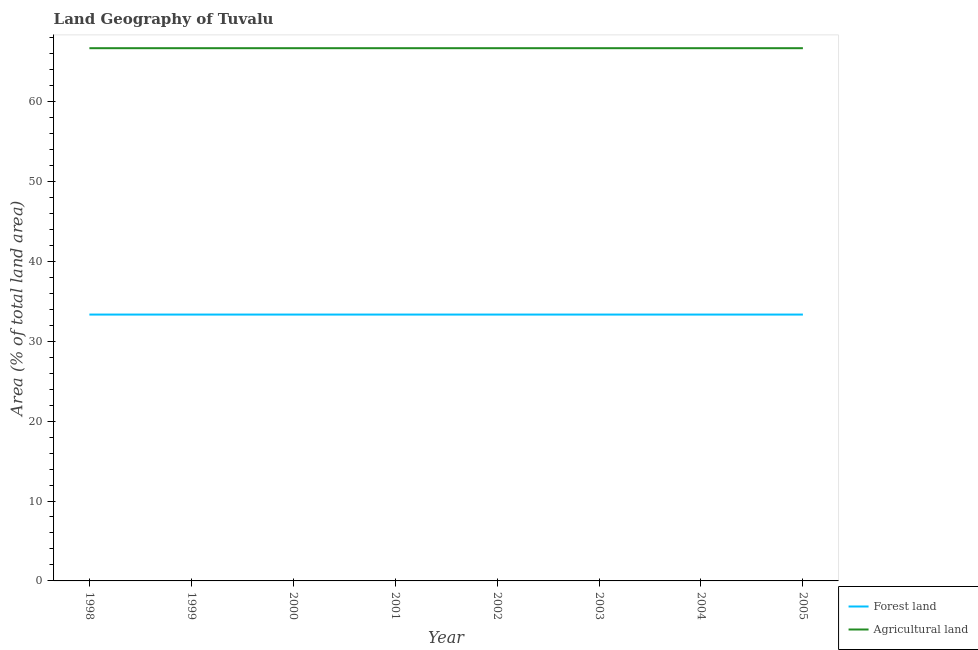Is the number of lines equal to the number of legend labels?
Keep it short and to the point. Yes. What is the percentage of land area under agriculture in 2002?
Your answer should be compact. 66.67. Across all years, what is the maximum percentage of land area under agriculture?
Make the answer very short. 66.67. Across all years, what is the minimum percentage of land area under forests?
Your answer should be very brief. 33.33. In which year was the percentage of land area under forests maximum?
Your answer should be very brief. 1998. What is the total percentage of land area under forests in the graph?
Provide a succinct answer. 266.67. What is the difference between the percentage of land area under agriculture in 2001 and that in 2004?
Provide a short and direct response. 0. What is the difference between the percentage of land area under forests in 1999 and the percentage of land area under agriculture in 2003?
Provide a short and direct response. -33.33. What is the average percentage of land area under forests per year?
Offer a very short reply. 33.33. In the year 2005, what is the difference between the percentage of land area under forests and percentage of land area under agriculture?
Your answer should be compact. -33.33. In how many years, is the percentage of land area under agriculture greater than 6 %?
Provide a short and direct response. 8. What is the ratio of the percentage of land area under forests in 1998 to that in 1999?
Keep it short and to the point. 1. Is the percentage of land area under agriculture in 1998 less than that in 2005?
Make the answer very short. No. What is the difference between the highest and the second highest percentage of land area under forests?
Your response must be concise. 0. In how many years, is the percentage of land area under agriculture greater than the average percentage of land area under agriculture taken over all years?
Offer a very short reply. 0. Does the percentage of land area under forests monotonically increase over the years?
Your response must be concise. No. How many years are there in the graph?
Give a very brief answer. 8. Are the values on the major ticks of Y-axis written in scientific E-notation?
Give a very brief answer. No. Where does the legend appear in the graph?
Your answer should be compact. Bottom right. How many legend labels are there?
Provide a short and direct response. 2. What is the title of the graph?
Offer a terse response. Land Geography of Tuvalu. What is the label or title of the Y-axis?
Provide a short and direct response. Area (% of total land area). What is the Area (% of total land area) of Forest land in 1998?
Keep it short and to the point. 33.33. What is the Area (% of total land area) of Agricultural land in 1998?
Provide a short and direct response. 66.67. What is the Area (% of total land area) in Forest land in 1999?
Provide a succinct answer. 33.33. What is the Area (% of total land area) in Agricultural land in 1999?
Offer a very short reply. 66.67. What is the Area (% of total land area) in Forest land in 2000?
Ensure brevity in your answer.  33.33. What is the Area (% of total land area) in Agricultural land in 2000?
Your answer should be very brief. 66.67. What is the Area (% of total land area) of Forest land in 2001?
Your answer should be compact. 33.33. What is the Area (% of total land area) of Agricultural land in 2001?
Provide a short and direct response. 66.67. What is the Area (% of total land area) in Forest land in 2002?
Your response must be concise. 33.33. What is the Area (% of total land area) in Agricultural land in 2002?
Provide a succinct answer. 66.67. What is the Area (% of total land area) of Forest land in 2003?
Offer a terse response. 33.33. What is the Area (% of total land area) of Agricultural land in 2003?
Provide a succinct answer. 66.67. What is the Area (% of total land area) of Forest land in 2004?
Your answer should be very brief. 33.33. What is the Area (% of total land area) of Agricultural land in 2004?
Provide a succinct answer. 66.67. What is the Area (% of total land area) of Forest land in 2005?
Your answer should be very brief. 33.33. What is the Area (% of total land area) of Agricultural land in 2005?
Your answer should be very brief. 66.67. Across all years, what is the maximum Area (% of total land area) of Forest land?
Your response must be concise. 33.33. Across all years, what is the maximum Area (% of total land area) in Agricultural land?
Ensure brevity in your answer.  66.67. Across all years, what is the minimum Area (% of total land area) of Forest land?
Your response must be concise. 33.33. Across all years, what is the minimum Area (% of total land area) in Agricultural land?
Make the answer very short. 66.67. What is the total Area (% of total land area) of Forest land in the graph?
Offer a very short reply. 266.67. What is the total Area (% of total land area) of Agricultural land in the graph?
Your response must be concise. 533.33. What is the difference between the Area (% of total land area) in Forest land in 1998 and that in 1999?
Keep it short and to the point. 0. What is the difference between the Area (% of total land area) in Agricultural land in 1998 and that in 1999?
Offer a terse response. 0. What is the difference between the Area (% of total land area) in Forest land in 1998 and that in 2000?
Give a very brief answer. 0. What is the difference between the Area (% of total land area) of Forest land in 1998 and that in 2001?
Your answer should be very brief. 0. What is the difference between the Area (% of total land area) in Forest land in 1998 and that in 2002?
Keep it short and to the point. 0. What is the difference between the Area (% of total land area) in Forest land in 1998 and that in 2003?
Offer a very short reply. 0. What is the difference between the Area (% of total land area) of Agricultural land in 1998 and that in 2003?
Ensure brevity in your answer.  0. What is the difference between the Area (% of total land area) of Forest land in 1998 and that in 2004?
Provide a short and direct response. 0. What is the difference between the Area (% of total land area) in Agricultural land in 1998 and that in 2004?
Your answer should be compact. 0. What is the difference between the Area (% of total land area) of Forest land in 1998 and that in 2005?
Your response must be concise. 0. What is the difference between the Area (% of total land area) of Agricultural land in 1999 and that in 2000?
Offer a very short reply. 0. What is the difference between the Area (% of total land area) in Forest land in 1999 and that in 2003?
Provide a succinct answer. 0. What is the difference between the Area (% of total land area) of Agricultural land in 2000 and that in 2001?
Your answer should be very brief. 0. What is the difference between the Area (% of total land area) in Agricultural land in 2000 and that in 2002?
Provide a short and direct response. 0. What is the difference between the Area (% of total land area) in Forest land in 2000 and that in 2003?
Give a very brief answer. 0. What is the difference between the Area (% of total land area) of Agricultural land in 2000 and that in 2003?
Offer a terse response. 0. What is the difference between the Area (% of total land area) of Agricultural land in 2001 and that in 2002?
Provide a succinct answer. 0. What is the difference between the Area (% of total land area) of Agricultural land in 2001 and that in 2003?
Your answer should be compact. 0. What is the difference between the Area (% of total land area) in Forest land in 2001 and that in 2004?
Offer a very short reply. 0. What is the difference between the Area (% of total land area) of Forest land in 2002 and that in 2003?
Your answer should be compact. 0. What is the difference between the Area (% of total land area) of Agricultural land in 2002 and that in 2003?
Provide a succinct answer. 0. What is the difference between the Area (% of total land area) of Forest land in 2002 and that in 2004?
Your answer should be very brief. 0. What is the difference between the Area (% of total land area) in Agricultural land in 2002 and that in 2004?
Offer a terse response. 0. What is the difference between the Area (% of total land area) of Forest land in 2002 and that in 2005?
Your response must be concise. 0. What is the difference between the Area (% of total land area) in Agricultural land in 2002 and that in 2005?
Offer a very short reply. 0. What is the difference between the Area (% of total land area) of Forest land in 2003 and that in 2004?
Provide a succinct answer. 0. What is the difference between the Area (% of total land area) in Forest land in 2003 and that in 2005?
Your response must be concise. 0. What is the difference between the Area (% of total land area) of Forest land in 2004 and that in 2005?
Give a very brief answer. 0. What is the difference between the Area (% of total land area) in Forest land in 1998 and the Area (% of total land area) in Agricultural land in 1999?
Your answer should be very brief. -33.33. What is the difference between the Area (% of total land area) in Forest land in 1998 and the Area (% of total land area) in Agricultural land in 2000?
Give a very brief answer. -33.33. What is the difference between the Area (% of total land area) in Forest land in 1998 and the Area (% of total land area) in Agricultural land in 2001?
Give a very brief answer. -33.33. What is the difference between the Area (% of total land area) of Forest land in 1998 and the Area (% of total land area) of Agricultural land in 2002?
Offer a very short reply. -33.33. What is the difference between the Area (% of total land area) in Forest land in 1998 and the Area (% of total land area) in Agricultural land in 2003?
Your answer should be very brief. -33.33. What is the difference between the Area (% of total land area) in Forest land in 1998 and the Area (% of total land area) in Agricultural land in 2004?
Your answer should be very brief. -33.33. What is the difference between the Area (% of total land area) of Forest land in 1998 and the Area (% of total land area) of Agricultural land in 2005?
Give a very brief answer. -33.33. What is the difference between the Area (% of total land area) of Forest land in 1999 and the Area (% of total land area) of Agricultural land in 2000?
Give a very brief answer. -33.33. What is the difference between the Area (% of total land area) of Forest land in 1999 and the Area (% of total land area) of Agricultural land in 2001?
Ensure brevity in your answer.  -33.33. What is the difference between the Area (% of total land area) of Forest land in 1999 and the Area (% of total land area) of Agricultural land in 2002?
Your answer should be compact. -33.33. What is the difference between the Area (% of total land area) in Forest land in 1999 and the Area (% of total land area) in Agricultural land in 2003?
Provide a succinct answer. -33.33. What is the difference between the Area (% of total land area) of Forest land in 1999 and the Area (% of total land area) of Agricultural land in 2004?
Provide a short and direct response. -33.33. What is the difference between the Area (% of total land area) of Forest land in 1999 and the Area (% of total land area) of Agricultural land in 2005?
Your response must be concise. -33.33. What is the difference between the Area (% of total land area) in Forest land in 2000 and the Area (% of total land area) in Agricultural land in 2001?
Provide a succinct answer. -33.33. What is the difference between the Area (% of total land area) of Forest land in 2000 and the Area (% of total land area) of Agricultural land in 2002?
Offer a very short reply. -33.33. What is the difference between the Area (% of total land area) in Forest land in 2000 and the Area (% of total land area) in Agricultural land in 2003?
Ensure brevity in your answer.  -33.33. What is the difference between the Area (% of total land area) of Forest land in 2000 and the Area (% of total land area) of Agricultural land in 2004?
Your response must be concise. -33.33. What is the difference between the Area (% of total land area) of Forest land in 2000 and the Area (% of total land area) of Agricultural land in 2005?
Offer a very short reply. -33.33. What is the difference between the Area (% of total land area) in Forest land in 2001 and the Area (% of total land area) in Agricultural land in 2002?
Your answer should be compact. -33.33. What is the difference between the Area (% of total land area) of Forest land in 2001 and the Area (% of total land area) of Agricultural land in 2003?
Provide a succinct answer. -33.33. What is the difference between the Area (% of total land area) in Forest land in 2001 and the Area (% of total land area) in Agricultural land in 2004?
Your answer should be compact. -33.33. What is the difference between the Area (% of total land area) of Forest land in 2001 and the Area (% of total land area) of Agricultural land in 2005?
Your answer should be very brief. -33.33. What is the difference between the Area (% of total land area) of Forest land in 2002 and the Area (% of total land area) of Agricultural land in 2003?
Your response must be concise. -33.33. What is the difference between the Area (% of total land area) in Forest land in 2002 and the Area (% of total land area) in Agricultural land in 2004?
Offer a very short reply. -33.33. What is the difference between the Area (% of total land area) of Forest land in 2002 and the Area (% of total land area) of Agricultural land in 2005?
Offer a very short reply. -33.33. What is the difference between the Area (% of total land area) in Forest land in 2003 and the Area (% of total land area) in Agricultural land in 2004?
Provide a short and direct response. -33.33. What is the difference between the Area (% of total land area) of Forest land in 2003 and the Area (% of total land area) of Agricultural land in 2005?
Your response must be concise. -33.33. What is the difference between the Area (% of total land area) in Forest land in 2004 and the Area (% of total land area) in Agricultural land in 2005?
Keep it short and to the point. -33.33. What is the average Area (% of total land area) in Forest land per year?
Your answer should be very brief. 33.33. What is the average Area (% of total land area) in Agricultural land per year?
Your answer should be very brief. 66.67. In the year 1998, what is the difference between the Area (% of total land area) in Forest land and Area (% of total land area) in Agricultural land?
Your answer should be compact. -33.33. In the year 1999, what is the difference between the Area (% of total land area) in Forest land and Area (% of total land area) in Agricultural land?
Ensure brevity in your answer.  -33.33. In the year 2000, what is the difference between the Area (% of total land area) in Forest land and Area (% of total land area) in Agricultural land?
Offer a terse response. -33.33. In the year 2001, what is the difference between the Area (% of total land area) in Forest land and Area (% of total land area) in Agricultural land?
Your answer should be compact. -33.33. In the year 2002, what is the difference between the Area (% of total land area) of Forest land and Area (% of total land area) of Agricultural land?
Provide a succinct answer. -33.33. In the year 2003, what is the difference between the Area (% of total land area) in Forest land and Area (% of total land area) in Agricultural land?
Your answer should be very brief. -33.33. In the year 2004, what is the difference between the Area (% of total land area) in Forest land and Area (% of total land area) in Agricultural land?
Give a very brief answer. -33.33. In the year 2005, what is the difference between the Area (% of total land area) of Forest land and Area (% of total land area) of Agricultural land?
Your answer should be compact. -33.33. What is the ratio of the Area (% of total land area) in Forest land in 1998 to that in 1999?
Give a very brief answer. 1. What is the ratio of the Area (% of total land area) in Agricultural land in 1998 to that in 1999?
Your response must be concise. 1. What is the ratio of the Area (% of total land area) of Forest land in 1998 to that in 2000?
Ensure brevity in your answer.  1. What is the ratio of the Area (% of total land area) in Agricultural land in 1998 to that in 2000?
Give a very brief answer. 1. What is the ratio of the Area (% of total land area) in Agricultural land in 1998 to that in 2001?
Provide a short and direct response. 1. What is the ratio of the Area (% of total land area) of Agricultural land in 1998 to that in 2002?
Keep it short and to the point. 1. What is the ratio of the Area (% of total land area) of Agricultural land in 1998 to that in 2003?
Ensure brevity in your answer.  1. What is the ratio of the Area (% of total land area) of Agricultural land in 1998 to that in 2005?
Make the answer very short. 1. What is the ratio of the Area (% of total land area) of Agricultural land in 1999 to that in 2000?
Your answer should be compact. 1. What is the ratio of the Area (% of total land area) in Forest land in 1999 to that in 2001?
Keep it short and to the point. 1. What is the ratio of the Area (% of total land area) in Agricultural land in 1999 to that in 2001?
Offer a terse response. 1. What is the ratio of the Area (% of total land area) of Agricultural land in 1999 to that in 2003?
Provide a short and direct response. 1. What is the ratio of the Area (% of total land area) of Forest land in 1999 to that in 2004?
Provide a succinct answer. 1. What is the ratio of the Area (% of total land area) of Forest land in 2000 to that in 2001?
Your answer should be very brief. 1. What is the ratio of the Area (% of total land area) in Forest land in 2000 to that in 2002?
Your response must be concise. 1. What is the ratio of the Area (% of total land area) in Agricultural land in 2000 to that in 2002?
Offer a very short reply. 1. What is the ratio of the Area (% of total land area) of Forest land in 2000 to that in 2003?
Your response must be concise. 1. What is the ratio of the Area (% of total land area) in Forest land in 2000 to that in 2005?
Provide a succinct answer. 1. What is the ratio of the Area (% of total land area) in Forest land in 2001 to that in 2002?
Keep it short and to the point. 1. What is the ratio of the Area (% of total land area) of Agricultural land in 2001 to that in 2002?
Your answer should be compact. 1. What is the ratio of the Area (% of total land area) in Forest land in 2001 to that in 2003?
Keep it short and to the point. 1. What is the ratio of the Area (% of total land area) in Agricultural land in 2001 to that in 2003?
Your answer should be very brief. 1. What is the ratio of the Area (% of total land area) of Forest land in 2001 to that in 2004?
Make the answer very short. 1. What is the ratio of the Area (% of total land area) of Agricultural land in 2001 to that in 2004?
Your answer should be compact. 1. What is the ratio of the Area (% of total land area) of Forest land in 2001 to that in 2005?
Ensure brevity in your answer.  1. What is the ratio of the Area (% of total land area) of Agricultural land in 2001 to that in 2005?
Your response must be concise. 1. What is the ratio of the Area (% of total land area) in Forest land in 2002 to that in 2003?
Ensure brevity in your answer.  1. What is the ratio of the Area (% of total land area) of Forest land in 2002 to that in 2004?
Offer a very short reply. 1. What is the ratio of the Area (% of total land area) in Forest land in 2003 to that in 2004?
Offer a terse response. 1. What is the ratio of the Area (% of total land area) of Forest land in 2003 to that in 2005?
Provide a succinct answer. 1. What is the difference between the highest and the second highest Area (% of total land area) in Agricultural land?
Provide a succinct answer. 0. What is the difference between the highest and the lowest Area (% of total land area) in Forest land?
Your response must be concise. 0. 